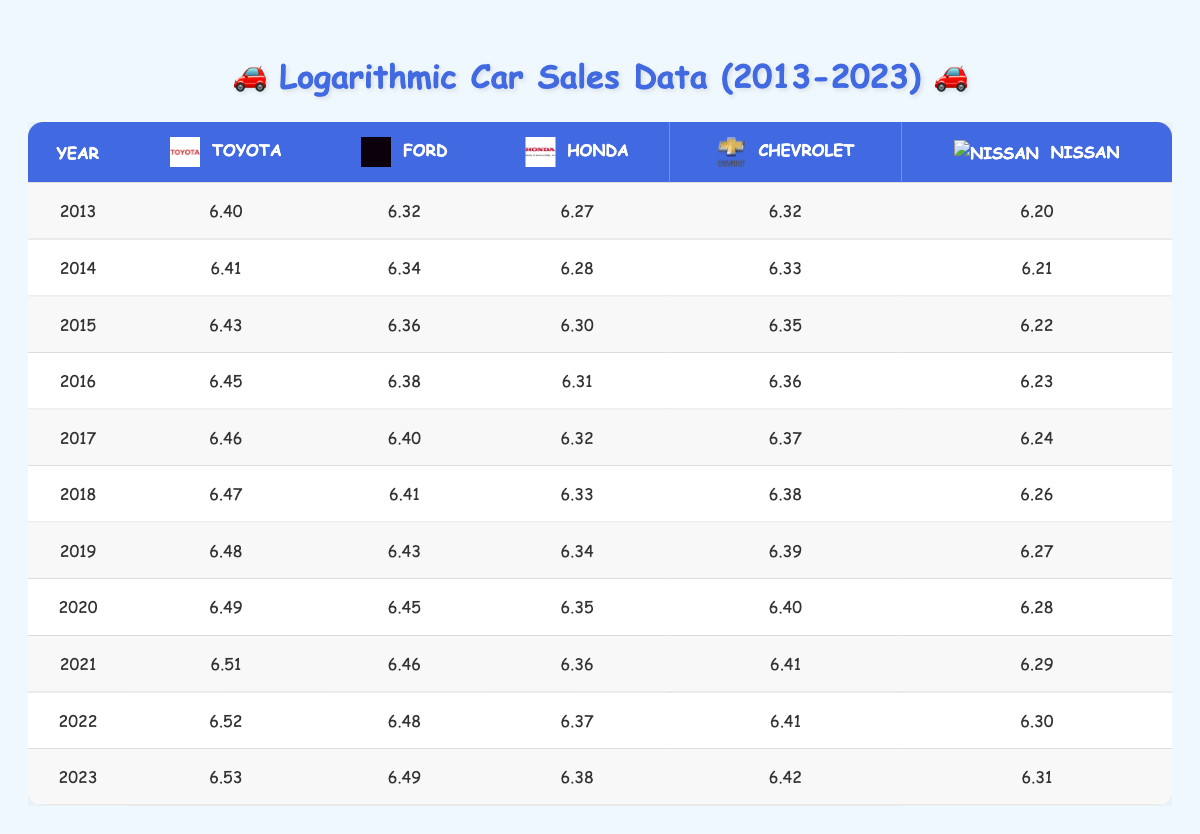What was the car sales value for Ford in 2020? In the year 2020, the table shows the logarithmic car sales value for Ford is 6.45. This value is derived from the actual sales data of 2,800,000 cars sold by Ford in that year, and the log value used in the table is calculated using a log base 10.
Answer: 6.45 Which brand had the highest sales in 2022? In the year 2022, Toyota had the highest logarithmic sales value of 6.52. Other brands had lower values: Ford (6.48), Honda (6.37), Chevrolet (6.41), and Nissan (6.30). Comparing these values indicates that Toyota led the sales.
Answer: Toyota What is the average logarithmic sales value for Honda over the decade? The sales values for Honda from 2013 to 2023 are: 6.27, 6.28, 6.30, 6.31, 6.32, 6.33, 6.34, 6.35, 6.36, and 6.38. Adding these values gives 63.3, and dividing by 10 (the number of years) results in an average of 6.33.
Answer: 6.33 Was there an increase in Toyota's sales from 2013 to 2019? The logarithmic values for Toyota from 2013 to 2019 are as follows: 6.40 (2013), 6.41 (2014), 6.43 (2015), 6.45 (2016), 6.46 (2017), 6.47 (2018), and 6.48 (2019). All these values steadily increase from the first year to the last, indicating an increase in sales for Toyota over this period.
Answer: Yes What is the difference in logarithmic sales values for Chevrolet between 2015 and 2023? In 2015, Chevrolet's logarithmic value was 6.35, and in 2023 it was 6.42. To find the difference, subtract the earlier value from the later value: 6.42 - 6.35 = 0.07. Therefore, Chevrolet's sales value increased by this amount over the span of the years.
Answer: 0.07 